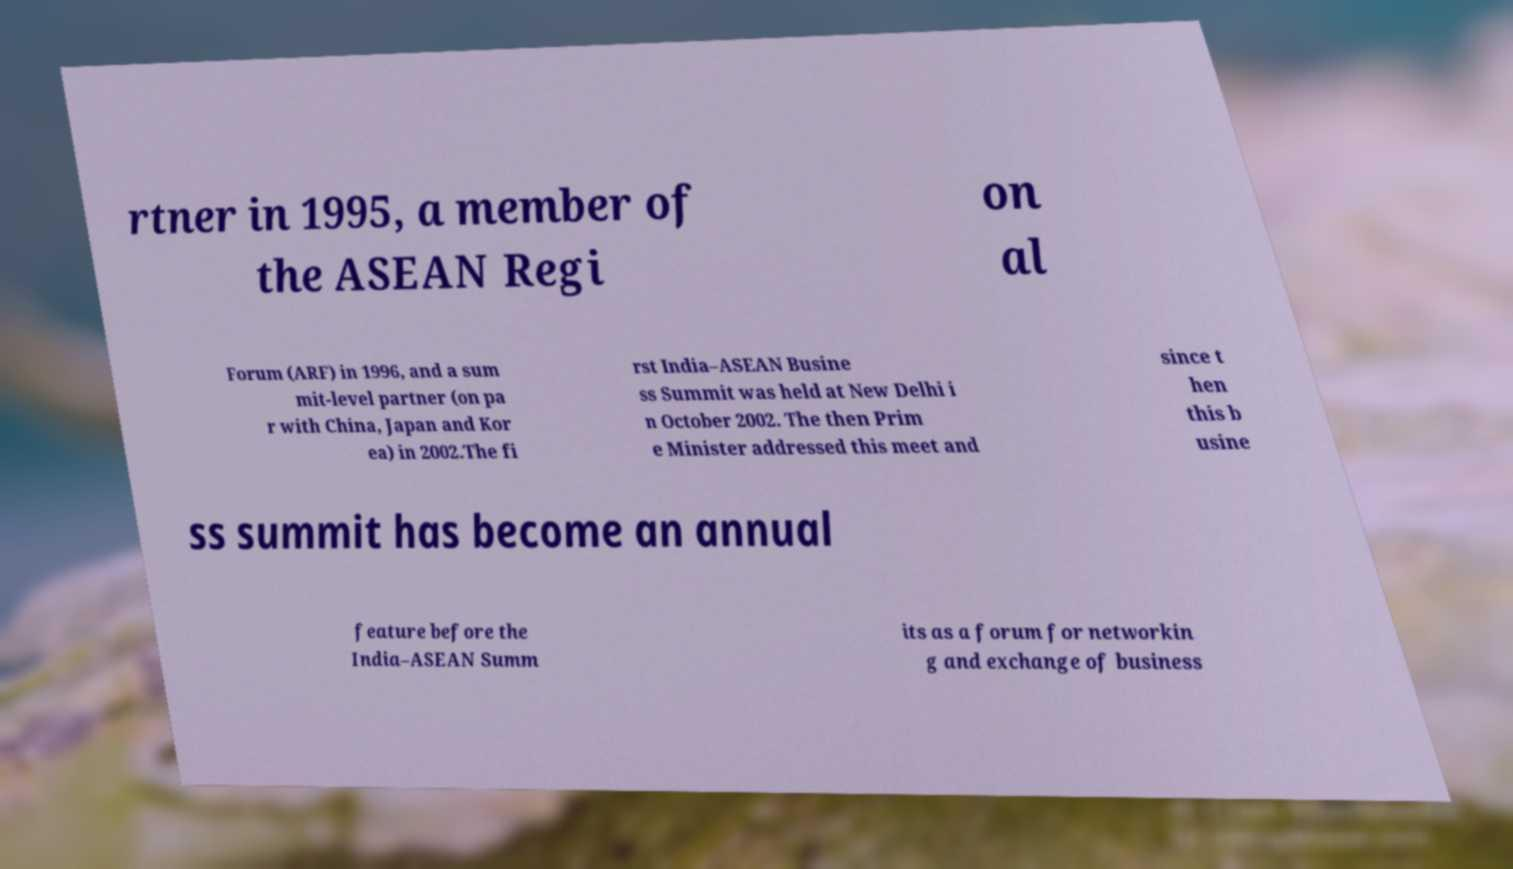Please identify and transcribe the text found in this image. rtner in 1995, a member of the ASEAN Regi on al Forum (ARF) in 1996, and a sum mit-level partner (on pa r with China, Japan and Kor ea) in 2002.The fi rst India–ASEAN Busine ss Summit was held at New Delhi i n October 2002. The then Prim e Minister addressed this meet and since t hen this b usine ss summit has become an annual feature before the India–ASEAN Summ its as a forum for networkin g and exchange of business 